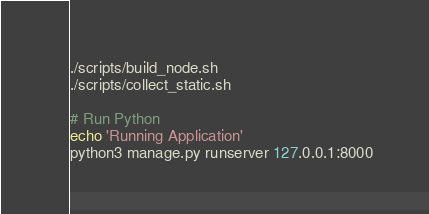<code> <loc_0><loc_0><loc_500><loc_500><_Bash_>./scripts/build_node.sh
./scripts/collect_static.sh

# Run Python
echo 'Running Application'
python3 manage.py runserver 127.0.0.1:8000</code> 